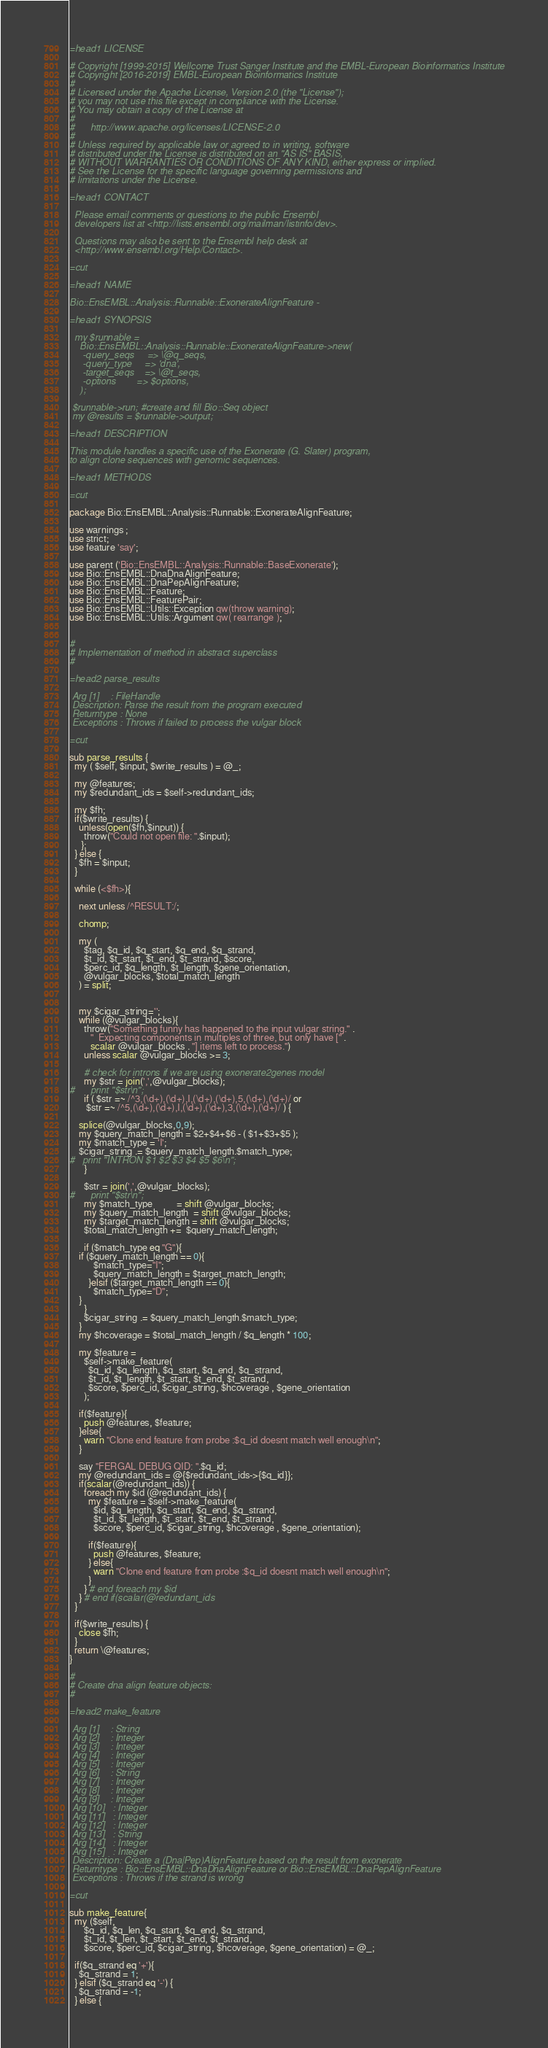<code> <loc_0><loc_0><loc_500><loc_500><_Perl_>=head1 LICENSE

# Copyright [1999-2015] Wellcome Trust Sanger Institute and the EMBL-European Bioinformatics Institute
# Copyright [2016-2019] EMBL-European Bioinformatics Institute
# 
# Licensed under the Apache License, Version 2.0 (the "License");
# you may not use this file except in compliance with the License.
# You may obtain a copy of the License at
# 
#      http://www.apache.org/licenses/LICENSE-2.0
# 
# Unless required by applicable law or agreed to in writing, software
# distributed under the License is distributed on an "AS IS" BASIS,
# WITHOUT WARRANTIES OR CONDITIONS OF ANY KIND, either express or implied.
# See the License for the specific language governing permissions and
# limitations under the License.

=head1 CONTACT

  Please email comments or questions to the public Ensembl
  developers list at <http://lists.ensembl.org/mailman/listinfo/dev>.

  Questions may also be sent to the Ensembl help desk at
  <http://www.ensembl.org/Help/Contact>.

=cut

=head1 NAME

Bio::EnsEMBL::Analysis::Runnable::ExonerateAlignFeature - 

=head1 SYNOPSIS

  my $runnable = 
    Bio::EnsEMBL::Analysis::Runnable::ExonerateAlignFeature->new(
     -query_seqs     => \@q_seqs,
     -query_type     => 'dna',
     -target_seqs    => \@t_seqs,
     -options        => $options,
    );

 $runnable->run; #create and fill Bio::Seq object
 my @results = $runnable->output;
 
=head1 DESCRIPTION

This module handles a specific use of the Exonerate (G. Slater) program, 
to align clone sequences with genomic sequences.

=head1 METHODS

=cut

package Bio::EnsEMBL::Analysis::Runnable::ExonerateAlignFeature;

use warnings ;
use strict;
use feature 'say';

use parent ('Bio::EnsEMBL::Analysis::Runnable::BaseExonerate');
use Bio::EnsEMBL::DnaDnaAlignFeature;
use Bio::EnsEMBL::DnaPepAlignFeature;
use Bio::EnsEMBL::Feature;
use Bio::EnsEMBL::FeaturePair;
use Bio::EnsEMBL::Utils::Exception qw(throw warning);
use Bio::EnsEMBL::Utils::Argument qw( rearrange );


#
# Implementation of method in abstract superclass
#

=head2 parse_results

 Arg [1]    : FileHandle
 Description: Parse the result from the program executed
 Returntype : None
 Exceptions : Throws if failed to process the vulgar block

=cut

sub parse_results {
  my ( $self, $input, $write_results ) = @_;

  my @features;
  my $redundant_ids = $self->redundant_ids;

  my $fh;
  if($write_results) {
    unless(open($fh,$input)) {
      throw("Could not open file: ".$input);
     };
  } else {
    $fh = $input;
  }

  while (<$fh>){

    next unless /^RESULT:/;

    chomp;

    my (
      $tag, $q_id, $q_start, $q_end, $q_strand, 
      $t_id, $t_start, $t_end, $t_strand, $score, 
      $perc_id, $q_length, $t_length, $gene_orientation,
      @vulgar_blocks, $total_match_length
    ) = split;


    my $cigar_string='';  
    while (@vulgar_blocks){
      throw("Something funny has happened to the input vulgar string." .
		 "  Expecting components in multiples of three, but only have [" .
		 scalar @vulgar_blocks . "] items left to process.")
      unless scalar @vulgar_blocks >= 3;

      # check for introns if we are using exonerate2genes model
      my $str = join(',',@vulgar_blocks);
#      print "$str\n";
      if ( $str =~ /^3,(\d+),(\d+),I,(\d+),(\d+),5,(\d+),(\d+)/ or
	   $str =~ /^5,(\d+),(\d+),I,(\d+),(\d+),3,(\d+),(\d+)/ ) {
	
	splice(@vulgar_blocks,0,9);
	my $query_match_length = $2+$4+$6 - ( $1+$3+$5 );
	my $match_type = 'I';
	$cigar_string .= $query_match_length.$match_type;
#	print "INTRON $1 $2 $3 $4 $5 $6\n";
      }

      $str = join(',',@vulgar_blocks);
#      print "$str\n";
      my $match_type          = shift @vulgar_blocks;
      my $query_match_length  = shift @vulgar_blocks;
      my $target_match_length = shift @vulgar_blocks;
      $total_match_length +=  $query_match_length;

      if ($match_type eq "G"){
	if ($query_match_length == 0){
          $match_type="I";
          $query_match_length = $target_match_length;
        }elsif ($target_match_length == 0){
          $match_type="D";
	}
      }    
      $cigar_string .= $query_match_length.$match_type;     
    }
    my $hcoverage = $total_match_length / $q_length * 100;

    my $feature = 
      $self->make_feature(
        $q_id, $q_length, $q_start, $q_end, $q_strand, 
        $t_id, $t_length, $t_start, $t_end, $t_strand, 
        $score, $perc_id, $cigar_string, $hcoverage , $gene_orientation
      );

    if($feature){
      push @features, $feature;
    }else{
      warn "Clone end feature from probe :$q_id doesnt match well enough\n";
    }

    say "FERGAL DEBUG QID: ".$q_id;
    my @redundant_ids = @{$redundant_ids->{$q_id}};
    if(scalar(@redundant_ids)) {
      foreach my $id (@redundant_ids) {
        my $feature = $self->make_feature(
          $id, $q_length, $q_start, $q_end, $q_strand,
          $t_id, $t_length, $t_start, $t_end, $t_strand,
          $score, $perc_id, $cigar_string, $hcoverage , $gene_orientation);

        if($feature){
          push @features, $feature;
        } else{
          warn "Clone end feature from probe :$q_id doesnt match well enough\n";
        }
      } # end foreach my $id
    } # end if(scalar(@redundant_ids
  }

  if($write_results) {
    close $fh;
  }
  return \@features;
}

#
# Create dna align feature objects: 
#

=head2 make_feature

 Arg [1]    : String
 Arg [2]    : Integer
 Arg [3]    : Integer
 Arg [4]    : Integer
 Arg [5]    : Integer
 Arg [6]    : String
 Arg [7]    : Integer
 Arg [8]    : Integer
 Arg [9]    : Integer
 Arg [10]   : Integer
 Arg [11]   : Integer
 Arg [12]   : Integer
 Arg [13]   : String
 Arg [14]   : Integer
 Arg [15]   : Integer
 Description: Create a (Dna|Pep)AlignFeature based on the result from exonerate
 Returntype : Bio::EnsEMBL::DnaDnaAlignFeature or Bio::EnsEMBL::DnaPepAlignFeature
 Exceptions : Throws if the strand is wrong

=cut

sub make_feature{
  my ($self,
      $q_id, $q_len, $q_start, $q_end, $q_strand,
      $t_id, $t_len, $t_start, $t_end, $t_strand,
      $score, $perc_id, $cigar_string, $hcoverage, $gene_orientation) = @_;
 
  if($q_strand eq '+'){
    $q_strand = 1;
  } elsif ($q_strand eq '-') {
    $q_strand = -1;
  } else {</code> 